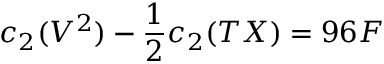<formula> <loc_0><loc_0><loc_500><loc_500>c _ { 2 } ( V ^ { 2 } ) - \frac { 1 } { 2 } c _ { 2 } ( T X ) = 9 6 F</formula> 